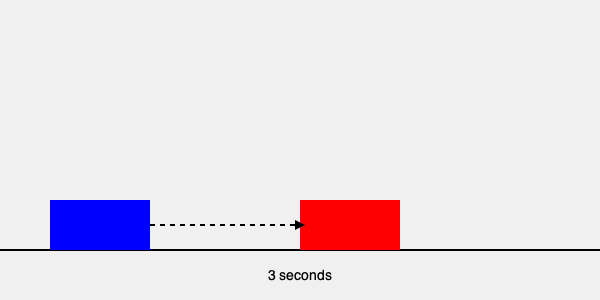As a driving examiner, you observe a student maintaining a 3-second following distance behind another vehicle on a dry, clear day. How would you assess this practice, and what feedback would you provide to the student driver? To assess this practice and provide feedback, we need to consider the following steps:

1. Understand the 3-second rule:
   - The 3-second rule is a general guideline for maintaining a safe following distance under ideal conditions.
   - It involves choosing a fixed point and counting the seconds between when the lead vehicle passes it and when your vehicle reaches it.

2. Evaluate the conditions:
   - The question states it's a dry, clear day, which represents ideal driving conditions.
   - In ideal conditions, the 3-second rule is typically considered appropriate.

3. Consider the benefits of the 3-second rule:
   - It provides enough time to react to sudden changes in traffic.
   - It allows for a safe stopping distance if the lead vehicle suddenly brakes.
   - The distance automatically adjusts for different speeds.

4. Assess potential improvements:
   - While 3 seconds is generally safe, encouraging a slightly longer following distance (e.g., 4 seconds) can provide an extra margin of safety.
   - Remind the student that the following distance should be increased in adverse conditions (rain, fog, night driving).

5. Formulate constructive feedback:
   - Praise the student for correctly applying the 3-second rule.
   - Encourage maintaining this practice as a minimum safe distance.
   - Suggest considering a slightly longer following distance for even greater safety.
   - Emphasize the importance of adjusting the distance based on road and weather conditions.
Answer: Positive assessment; maintain 3-second minimum, consider 4 seconds for extra safety, and adjust for conditions. 